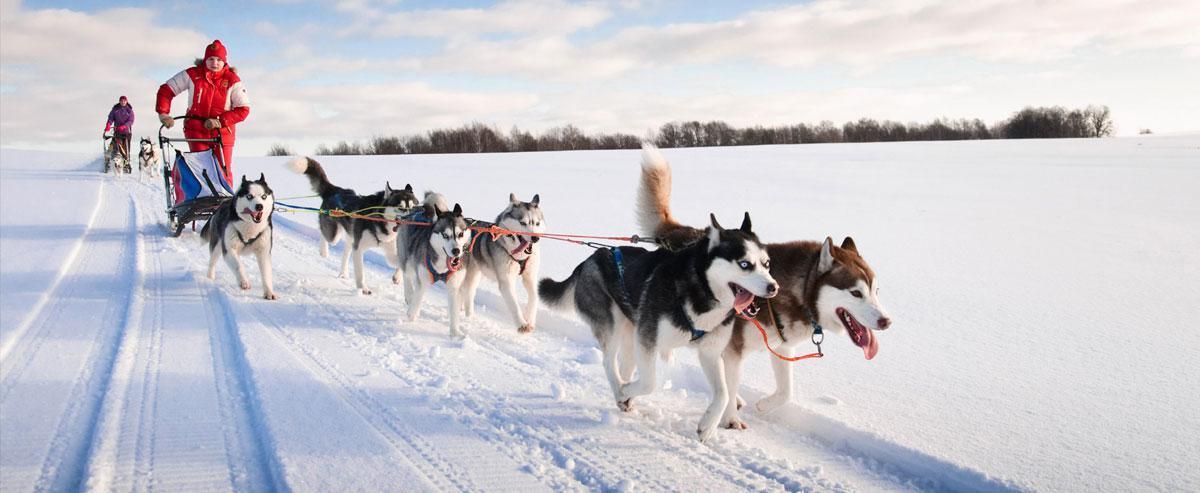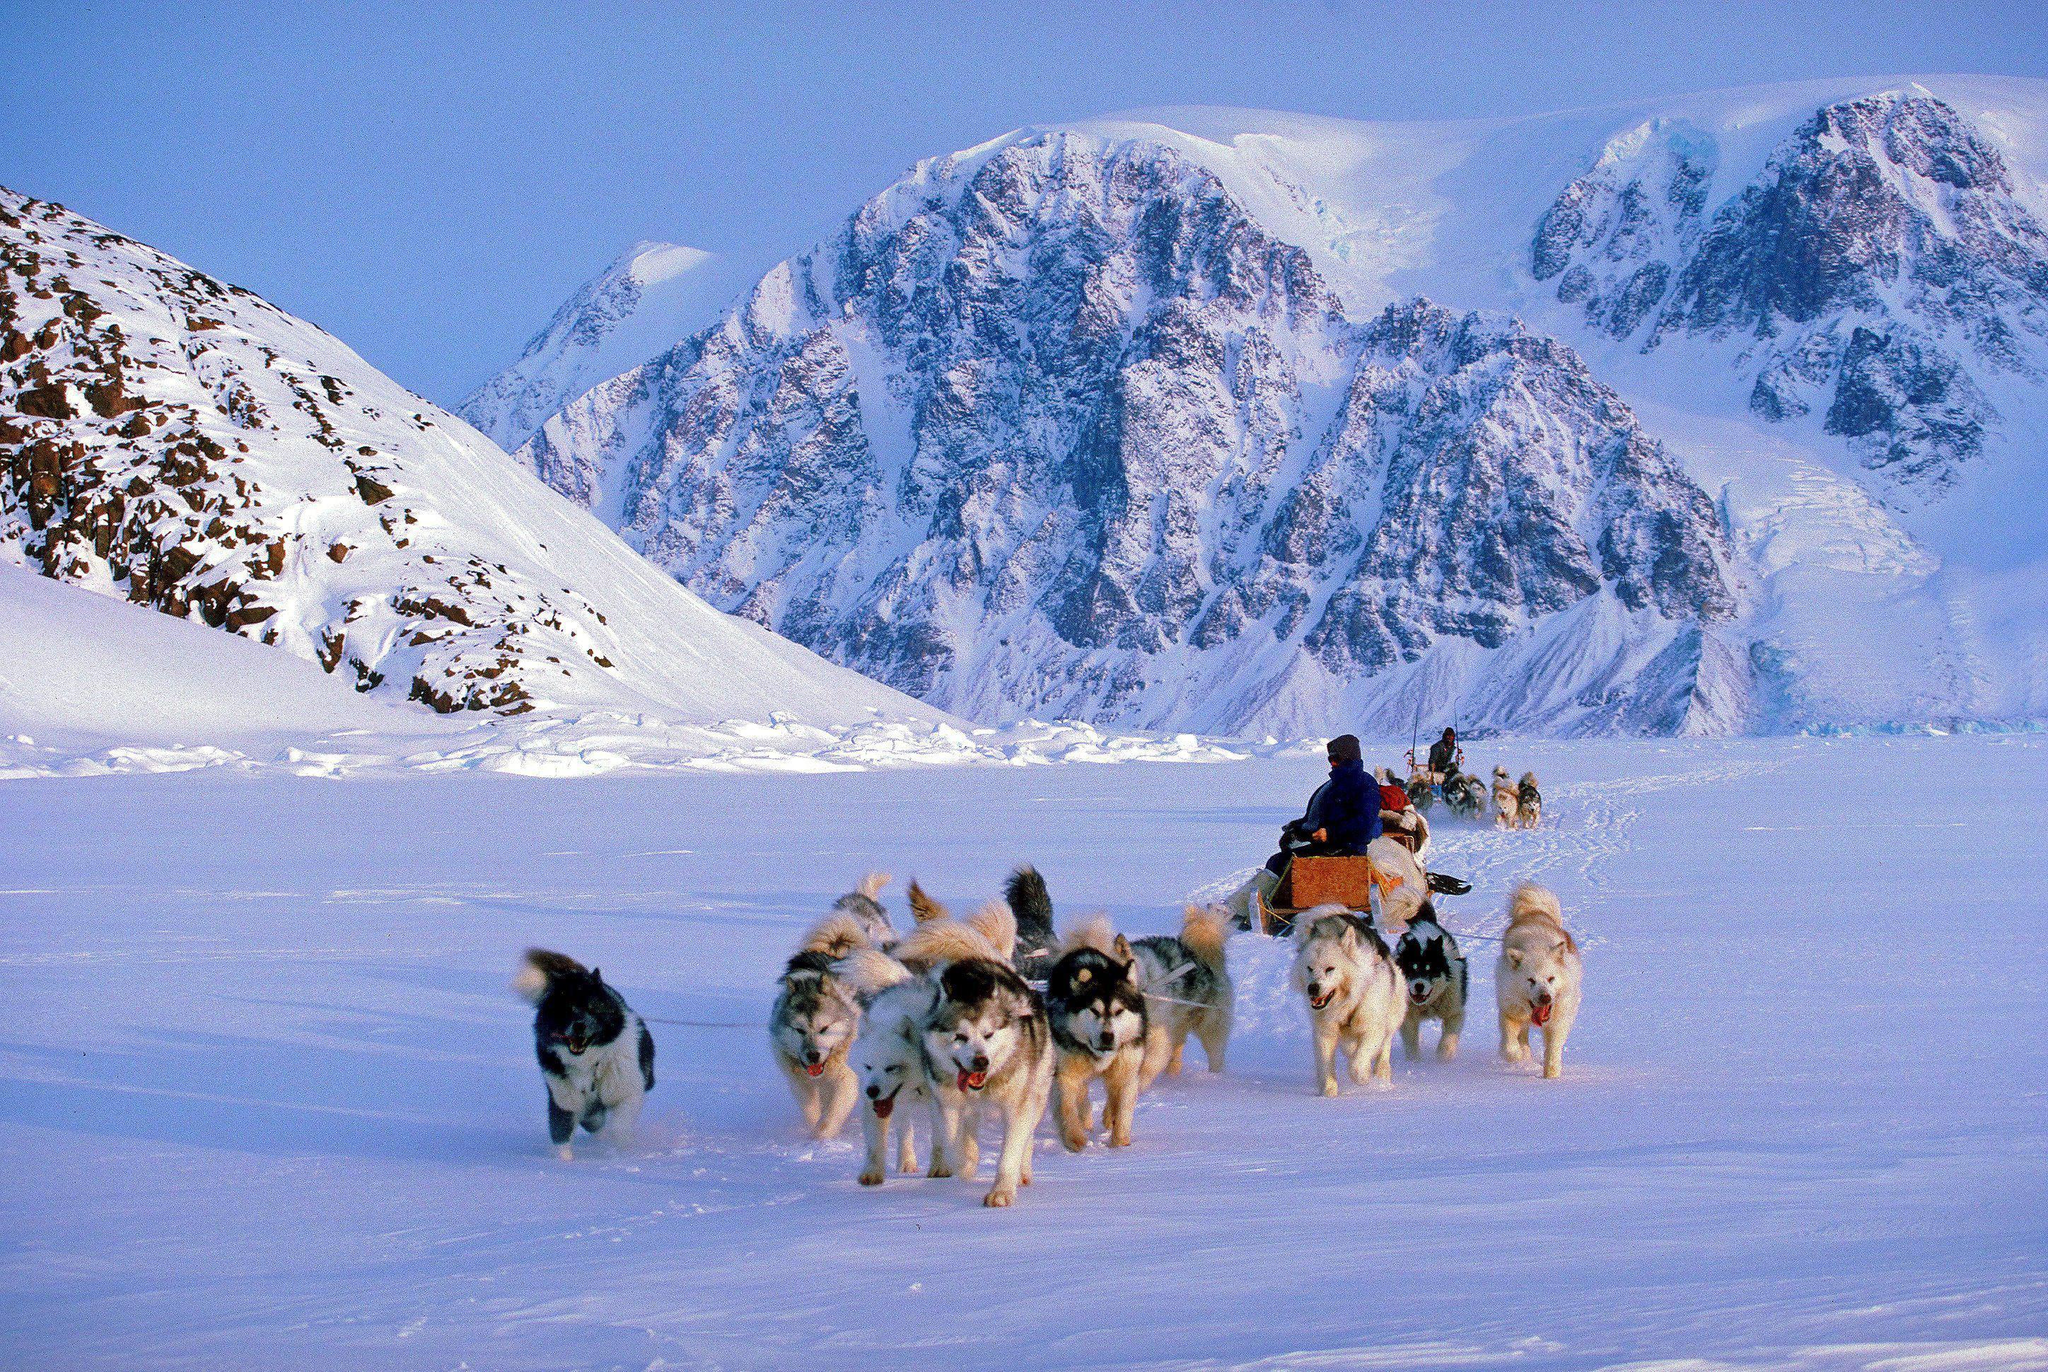The first image is the image on the left, the second image is the image on the right. Given the left and right images, does the statement "There are two or more dog sled teams in the left image." hold true? Answer yes or no. Yes. The first image is the image on the left, the second image is the image on the right. Assess this claim about the two images: "The lead dog sled teams in the left and right images head forward but are angled slightly away from each other so they would not collide.". Correct or not? Answer yes or no. No. 